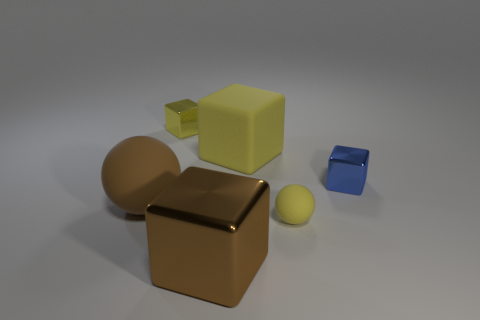What size is the sphere that is the same color as the big metal thing?
Keep it short and to the point. Large. Do the cube in front of the small blue shiny cube and the matte thing in front of the large brown rubber thing have the same size?
Keep it short and to the point. No. Is the number of yellow objects less than the number of brown cubes?
Offer a very short reply. No. What number of metallic blocks are behind the blue shiny object?
Provide a short and direct response. 1. What material is the blue cube?
Your response must be concise. Metal. Does the small rubber ball have the same color as the matte cube?
Provide a short and direct response. Yes. Are there fewer tiny objects to the right of the large shiny object than big metal blocks?
Ensure brevity in your answer.  No. There is a matte object left of the brown shiny object; what is its color?
Your response must be concise. Brown. The yellow shiny thing has what shape?
Provide a short and direct response. Cube. Are there any rubber things that are behind the tiny object in front of the blue metallic thing behind the brown metal thing?
Ensure brevity in your answer.  Yes. 